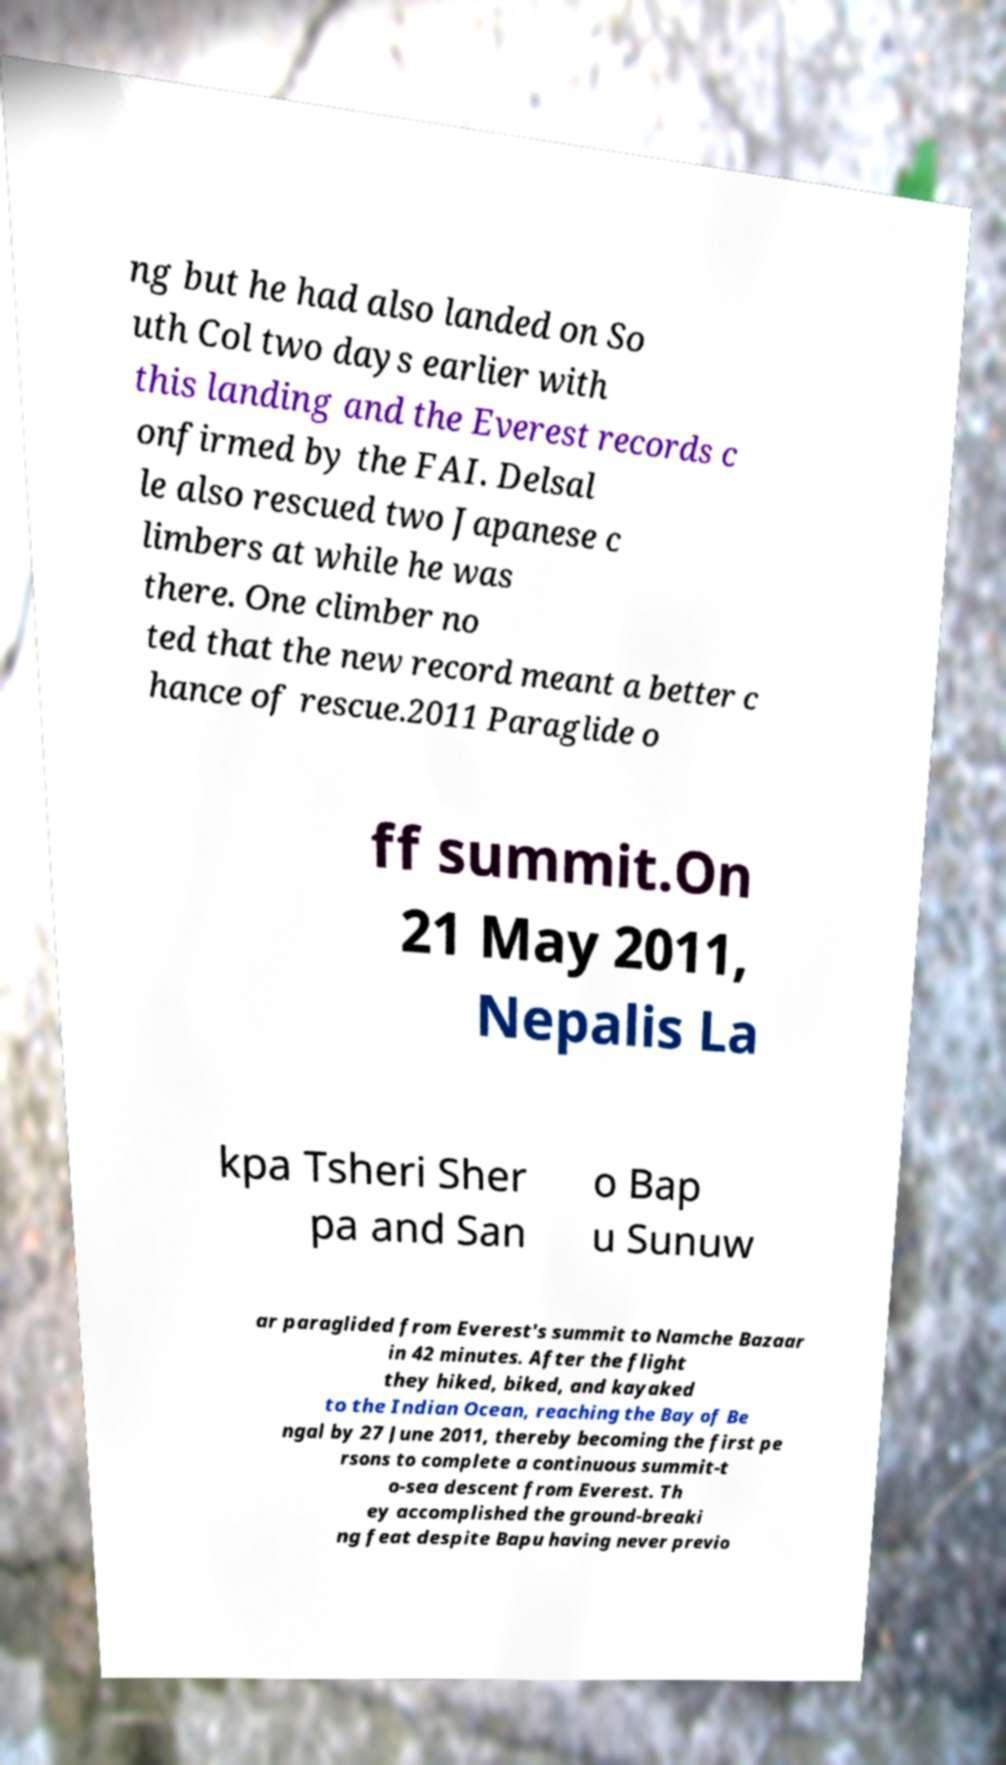What messages or text are displayed in this image? I need them in a readable, typed format. ng but he had also landed on So uth Col two days earlier with this landing and the Everest records c onfirmed by the FAI. Delsal le also rescued two Japanese c limbers at while he was there. One climber no ted that the new record meant a better c hance of rescue.2011 Paraglide o ff summit.On 21 May 2011, Nepalis La kpa Tsheri Sher pa and San o Bap u Sunuw ar paraglided from Everest's summit to Namche Bazaar in 42 minutes. After the flight they hiked, biked, and kayaked to the Indian Ocean, reaching the Bay of Be ngal by 27 June 2011, thereby becoming the first pe rsons to complete a continuous summit-t o-sea descent from Everest. Th ey accomplished the ground-breaki ng feat despite Bapu having never previo 